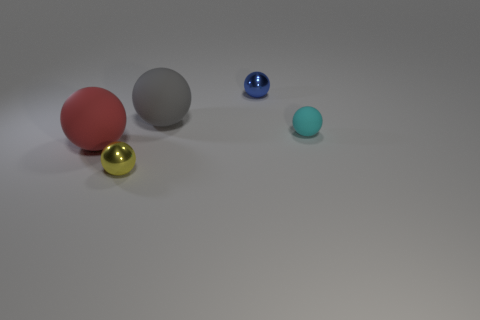There is a metal object on the left side of the tiny blue sphere; does it have the same shape as the big gray matte thing?
Your response must be concise. Yes. Are there any large objects of the same shape as the tiny matte object?
Provide a short and direct response. Yes. What is the shape of the shiny object on the left side of the big ball that is behind the big red thing?
Ensure brevity in your answer.  Sphere. How many balls have the same material as the big gray object?
Your response must be concise. 2. What color is the other sphere that is the same material as the blue ball?
Offer a terse response. Yellow. How big is the thing behind the large ball to the right of the small metallic ball in front of the big red rubber ball?
Provide a succinct answer. Small. Are there fewer small metal things than small rubber things?
Give a very brief answer. No. What color is the other big rubber thing that is the same shape as the red object?
Your answer should be compact. Gray. Are there any small metal balls behind the small ball that is in front of the big object that is in front of the tiny rubber object?
Give a very brief answer. Yes. Do the red rubber thing and the small yellow thing have the same shape?
Your answer should be compact. Yes. 